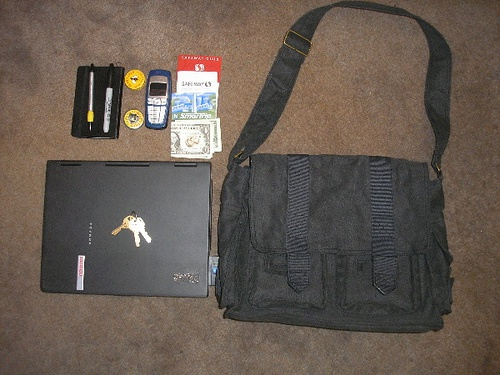Describe the objects in this image and their specific colors. I can see handbag in black and gray tones, laptop in black and gray tones, and cell phone in black, white, darkgray, and gray tones in this image. 